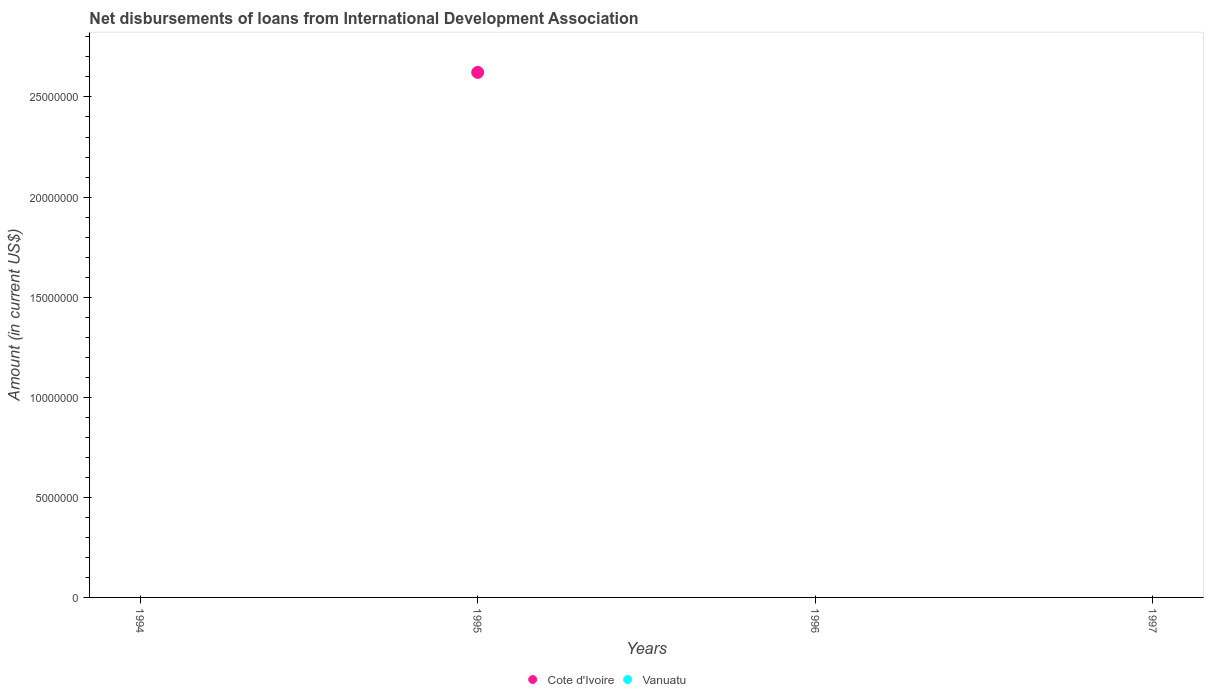Across all years, what is the maximum amount of loans disbursed in Cote d'Ivoire?
Ensure brevity in your answer.  2.62e+07. Across all years, what is the minimum amount of loans disbursed in Cote d'Ivoire?
Ensure brevity in your answer.  0. What is the total amount of loans disbursed in Vanuatu in the graph?
Give a very brief answer. 0. What is the difference between the amount of loans disbursed in Cote d'Ivoire in 1995 and the amount of loans disbursed in Vanuatu in 1996?
Your answer should be very brief. 2.62e+07. What is the average amount of loans disbursed in Cote d'Ivoire per year?
Your answer should be compact. 6.56e+06. What is the difference between the highest and the lowest amount of loans disbursed in Cote d'Ivoire?
Your answer should be very brief. 2.62e+07. Is the amount of loans disbursed in Vanuatu strictly greater than the amount of loans disbursed in Cote d'Ivoire over the years?
Provide a short and direct response. No. Is the amount of loans disbursed in Vanuatu strictly less than the amount of loans disbursed in Cote d'Ivoire over the years?
Keep it short and to the point. No. What is the difference between two consecutive major ticks on the Y-axis?
Offer a terse response. 5.00e+06. Are the values on the major ticks of Y-axis written in scientific E-notation?
Your response must be concise. No. Does the graph contain any zero values?
Your answer should be very brief. Yes. Does the graph contain grids?
Your response must be concise. No. What is the title of the graph?
Your answer should be very brief. Net disbursements of loans from International Development Association. What is the label or title of the Y-axis?
Your response must be concise. Amount (in current US$). What is the Amount (in current US$) of Cote d'Ivoire in 1995?
Give a very brief answer. 2.62e+07. What is the Amount (in current US$) in Vanuatu in 1995?
Your answer should be compact. 0. What is the Amount (in current US$) of Vanuatu in 1996?
Keep it short and to the point. 0. What is the Amount (in current US$) in Vanuatu in 1997?
Offer a terse response. 0. Across all years, what is the maximum Amount (in current US$) in Cote d'Ivoire?
Make the answer very short. 2.62e+07. What is the total Amount (in current US$) in Cote d'Ivoire in the graph?
Your answer should be compact. 2.62e+07. What is the total Amount (in current US$) in Vanuatu in the graph?
Your answer should be very brief. 0. What is the average Amount (in current US$) of Cote d'Ivoire per year?
Offer a very short reply. 6.56e+06. What is the average Amount (in current US$) in Vanuatu per year?
Your answer should be very brief. 0. What is the difference between the highest and the lowest Amount (in current US$) in Cote d'Ivoire?
Offer a terse response. 2.62e+07. 